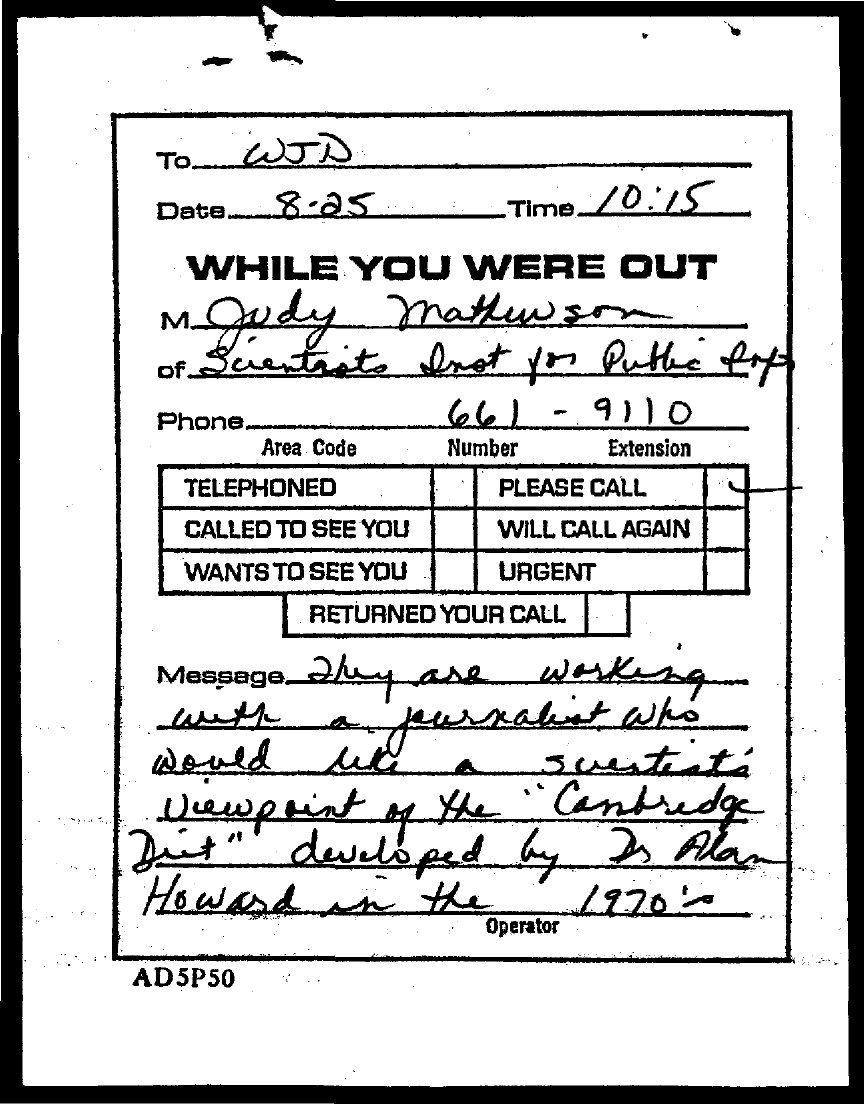To whom, the message is addressed?
Offer a terse response. WJD. What is the date mentioned in this document?
Offer a very short reply. 8.25. What is the time mentioned in this document?
Give a very brief answer. 10:15. What is the phone no of Judy mathewson?
Make the answer very short. 661-9110. 